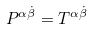<formula> <loc_0><loc_0><loc_500><loc_500>P ^ { \alpha \dot { \beta } } = T ^ { \alpha \dot { \beta } }</formula> 